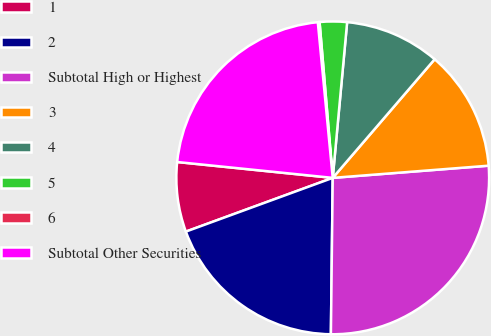Convert chart. <chart><loc_0><loc_0><loc_500><loc_500><pie_chart><fcel>1<fcel>2<fcel>Subtotal High or Highest<fcel>3<fcel>4<fcel>5<fcel>6<fcel>Subtotal Other Securities<nl><fcel>7.2%<fcel>19.23%<fcel>26.43%<fcel>12.46%<fcel>9.83%<fcel>2.81%<fcel>0.18%<fcel>21.86%<nl></chart> 